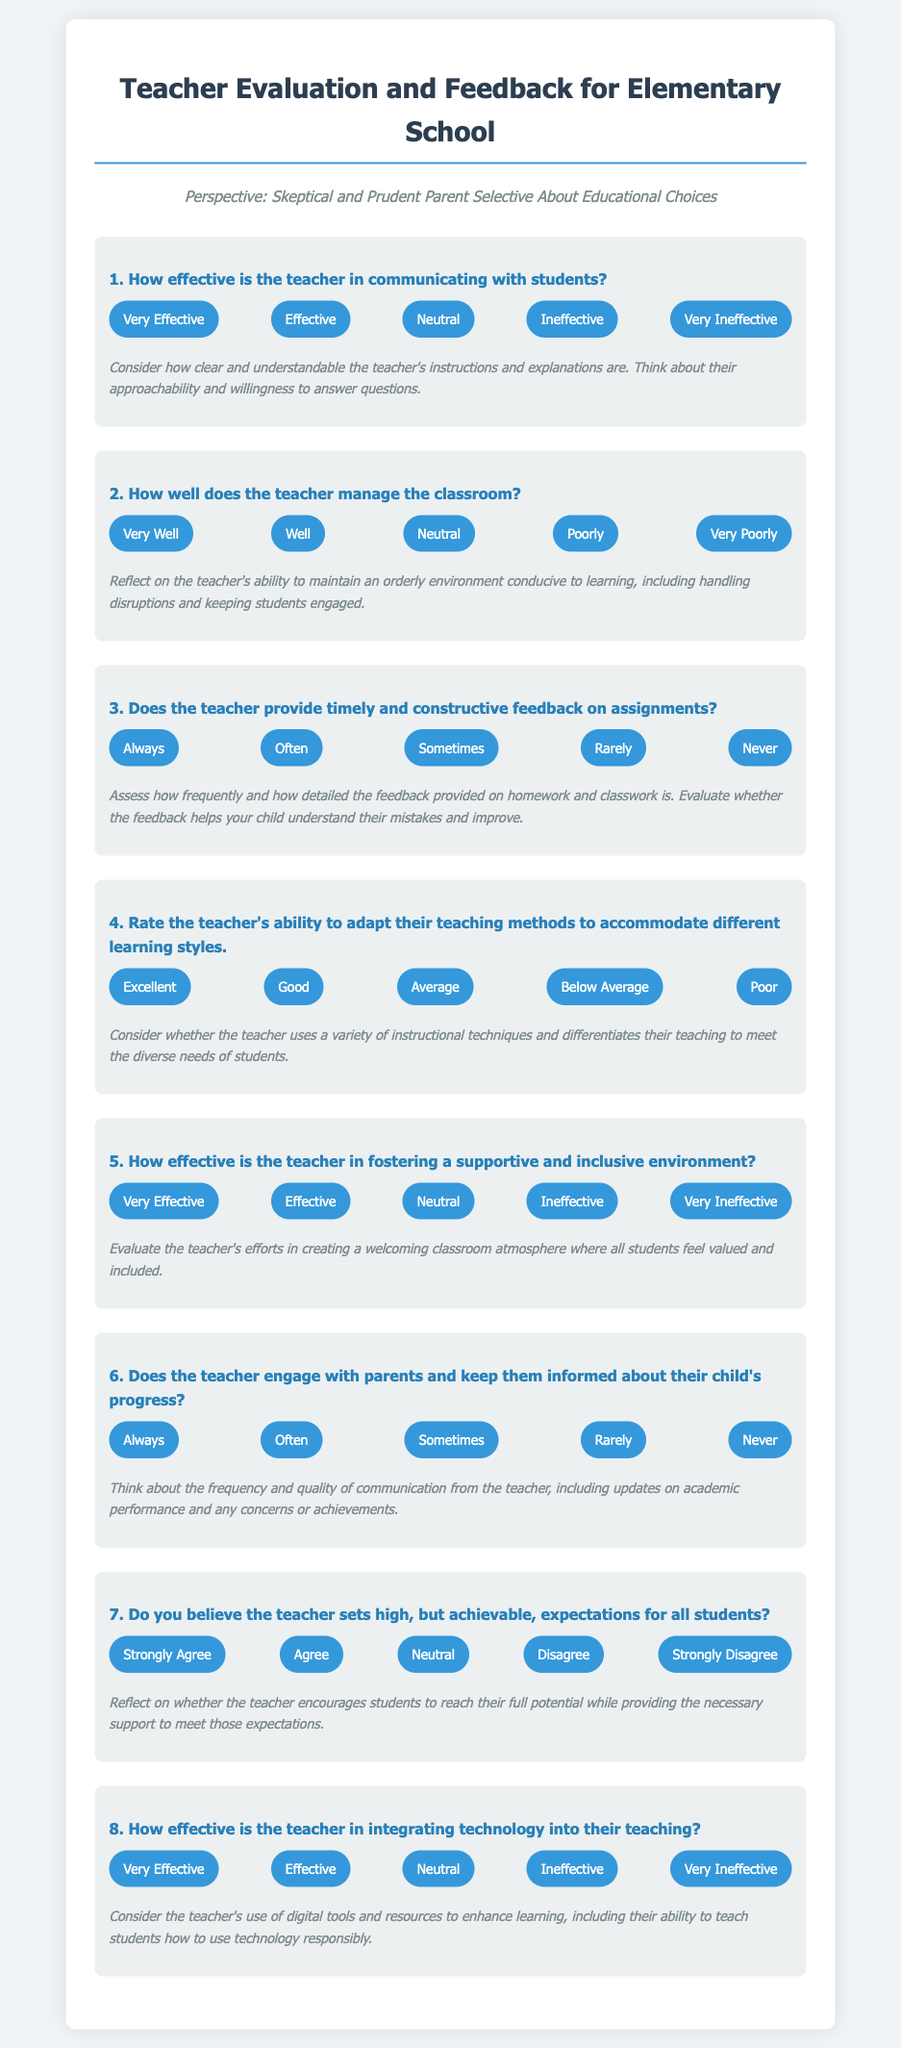What is the title of the document? The title of the document is specified in the header section of the HTML code.
Answer: Teacher Evaluation and Feedback for Elementary School How many main questions are included in the document? The number of main questions can be counted directly from the section containing each question in the HTML code.
Answer: 8 What is the first option for the effectiveness of the teacher's communication with students? The options for communication effectiveness are listed in a specific sequence in the document.
Answer: Very Effective What feedback frequency option is listed as "Never"? Each question has options for response, and "Never" is one of the responses under feedback on assignments.
Answer: Never Which area does the teacher need to manage well? The document specifically asks about classroom management under one of the questions.
Answer: Classroom Which question assesses the teacher's use of technology? The relevant question identifies the specific area concerning technology integration in teaching.
Answer: How effective is the teacher in integrating technology into their teaching? What are the criteria for evaluating classroom management? The criteria are mentioned in the notes under the classroom management question in the document.
Answer: Orderly environment and handling disruptions What is the range of feedback options for assignments? The frequency options listed provide a range for assessing assignment feedback throughout the document.
Answer: Always, Often, Sometimes, Rarely, Never 